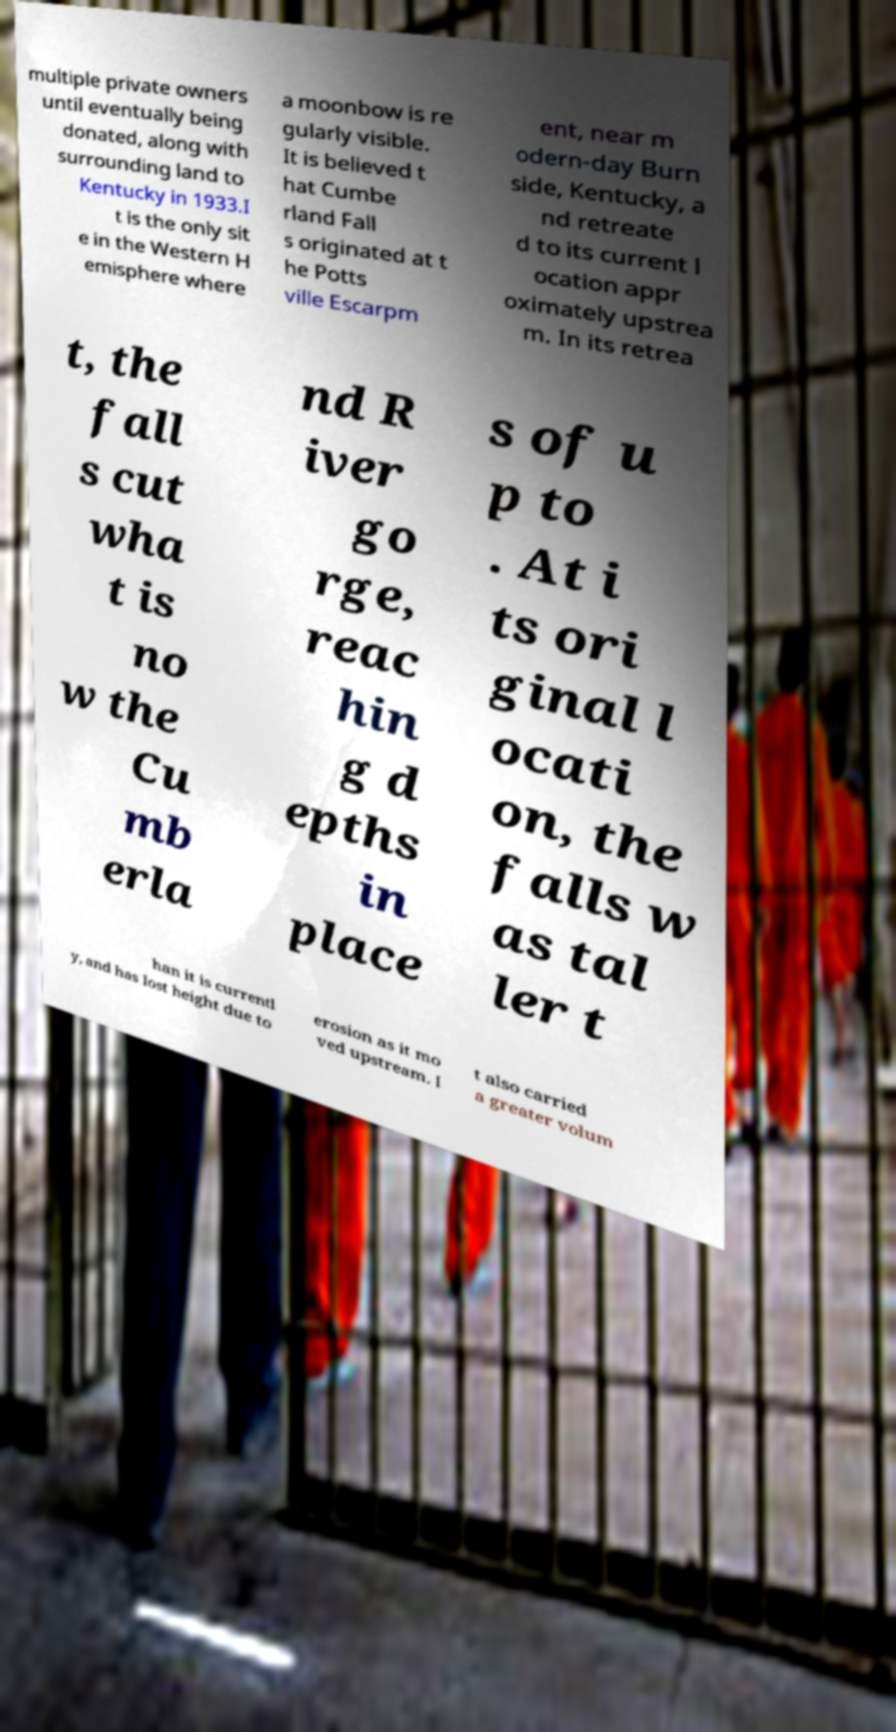Please read and relay the text visible in this image. What does it say? multiple private owners until eventually being donated, along with surrounding land to Kentucky in 1933.I t is the only sit e in the Western H emisphere where a moonbow is re gularly visible. It is believed t hat Cumbe rland Fall s originated at t he Potts ville Escarpm ent, near m odern-day Burn side, Kentucky, a nd retreate d to its current l ocation appr oximately upstrea m. In its retrea t, the fall s cut wha t is no w the Cu mb erla nd R iver go rge, reac hin g d epths in place s of u p to . At i ts ori ginal l ocati on, the falls w as tal ler t han it is currentl y, and has lost height due to erosion as it mo ved upstream. I t also carried a greater volum 